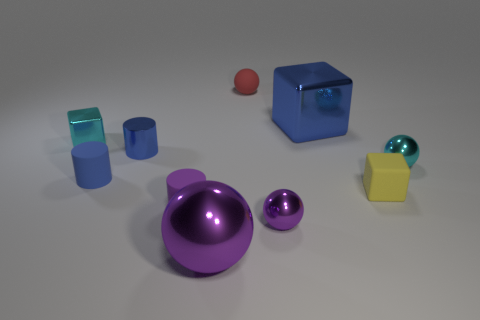Subtract all cubes. How many objects are left? 7 Add 3 large blue matte spheres. How many large blue matte spheres exist? 3 Subtract 0 yellow spheres. How many objects are left? 10 Subtract all purple objects. Subtract all large blue objects. How many objects are left? 6 Add 8 blue cylinders. How many blue cylinders are left? 10 